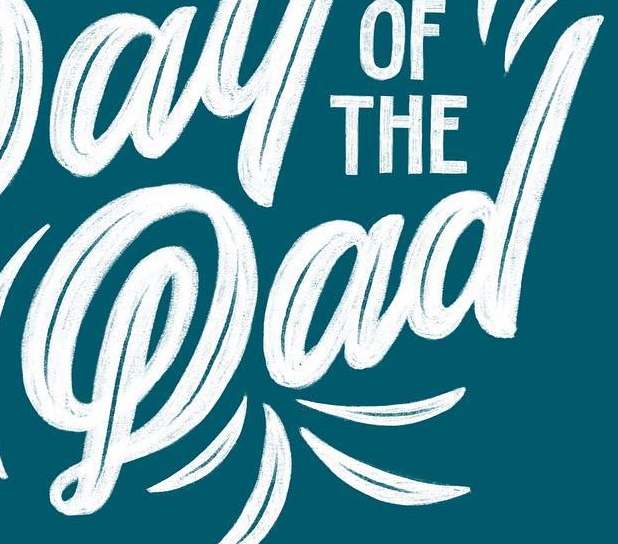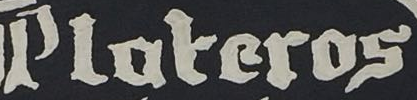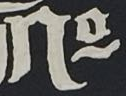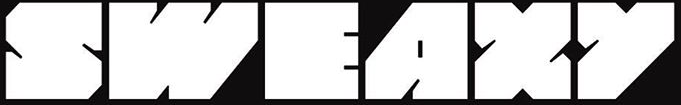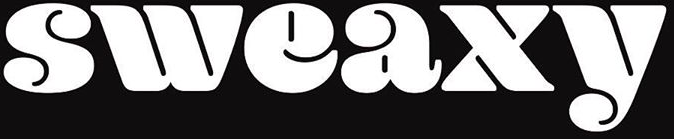What text appears in these images from left to right, separated by a semicolon? Pad; Ploteros; No; SWEAXY; sweaxy 